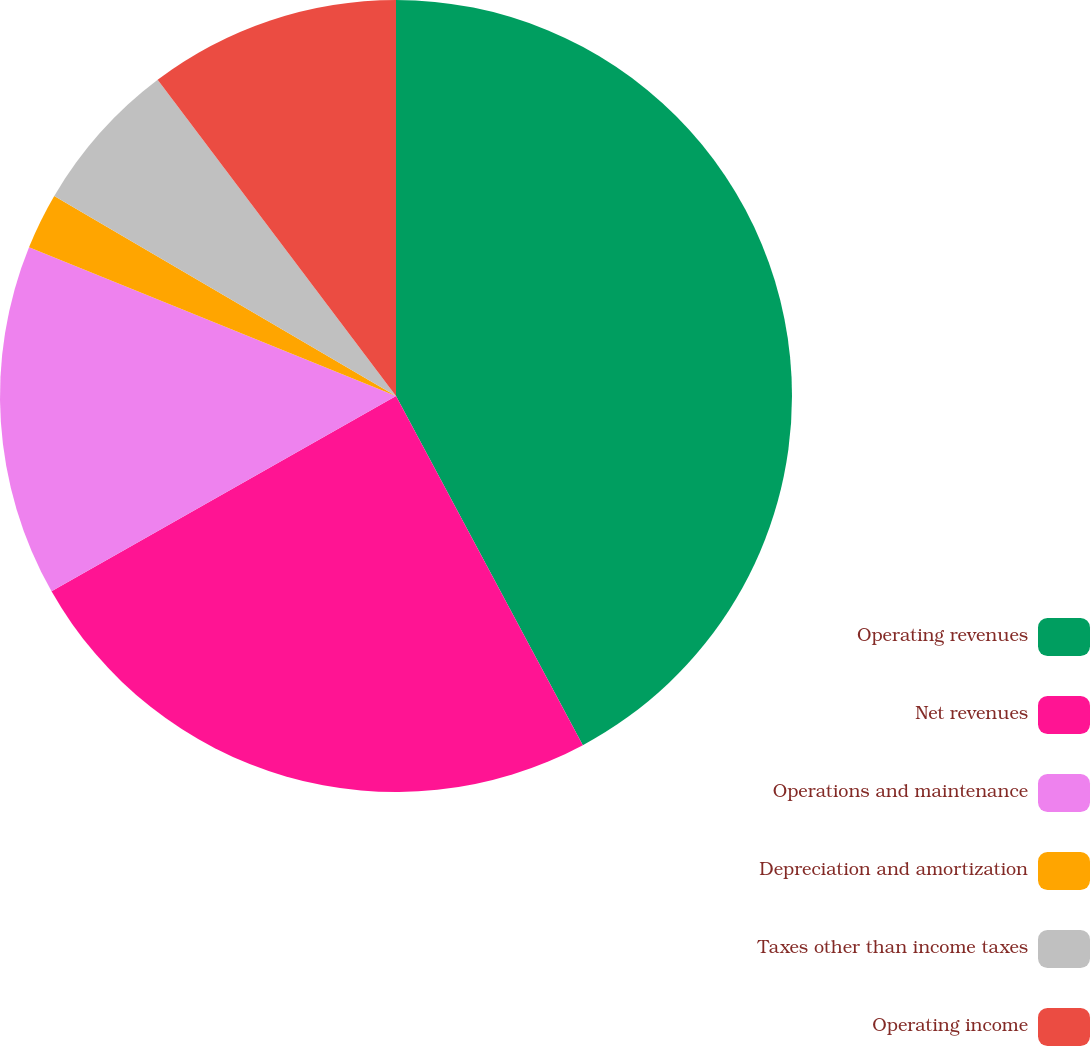Convert chart to OTSL. <chart><loc_0><loc_0><loc_500><loc_500><pie_chart><fcel>Operating revenues<fcel>Net revenues<fcel>Operations and maintenance<fcel>Depreciation and amortization<fcel>Taxes other than income taxes<fcel>Operating income<nl><fcel>42.18%<fcel>24.61%<fcel>14.34%<fcel>2.3%<fcel>6.29%<fcel>10.28%<nl></chart> 